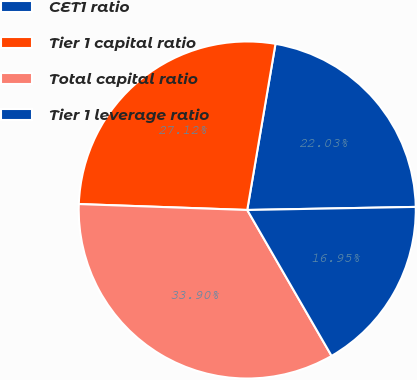<chart> <loc_0><loc_0><loc_500><loc_500><pie_chart><fcel>CET1 ratio<fcel>Tier 1 capital ratio<fcel>Total capital ratio<fcel>Tier 1 leverage ratio<nl><fcel>22.03%<fcel>27.12%<fcel>33.9%<fcel>16.95%<nl></chart> 